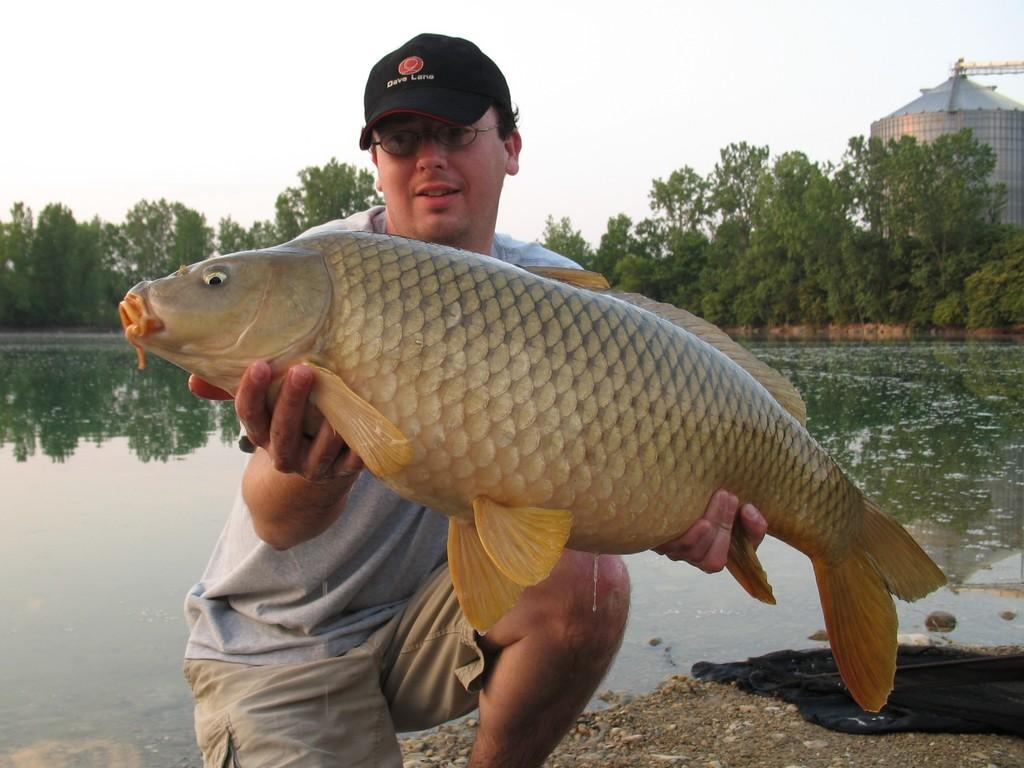What is the person in the image holding? The person is holding a fish in the image. What type of natural environment is depicted in the image? There are trees and water visible in the image, suggesting a natural setting. What structure can be seen in the image? There is a tank in the image. What is visible in the sky in the image? The sky is visible in the image. How many cracks are visible on the fish in the image? There are no cracks visible on the fish in the image. What type of hook is used to catch the fish in the image? There is no hook visible in the image, as the person is already holding the fish. 